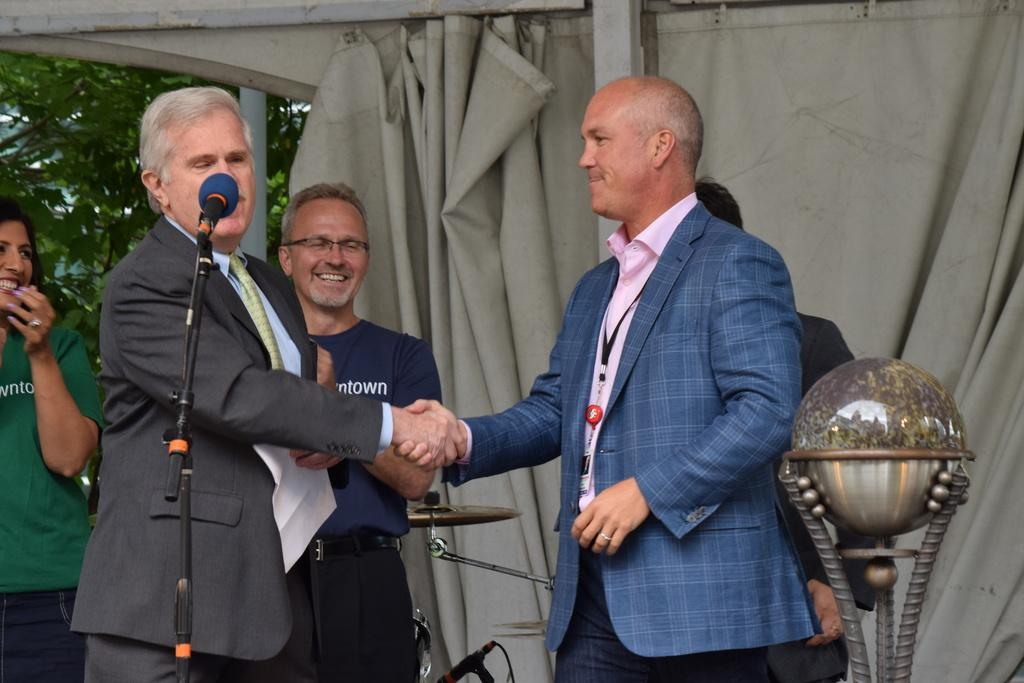How many people are present in the image? There are five persons in the image. What object can be seen in the image? There is a microphone in the image. Can you describe another object in the image? There is a musical instrument in the image. What type of natural element is present in the image? There is a tree in the image. What type of covering is present in the image? There is a curtain in the image. What is the best way to avoid the war scene depicted in the image? There is no war scene or any reference to war in the image; it features five persons, a microphone, a musical instrument, a tree, and a curtain. 